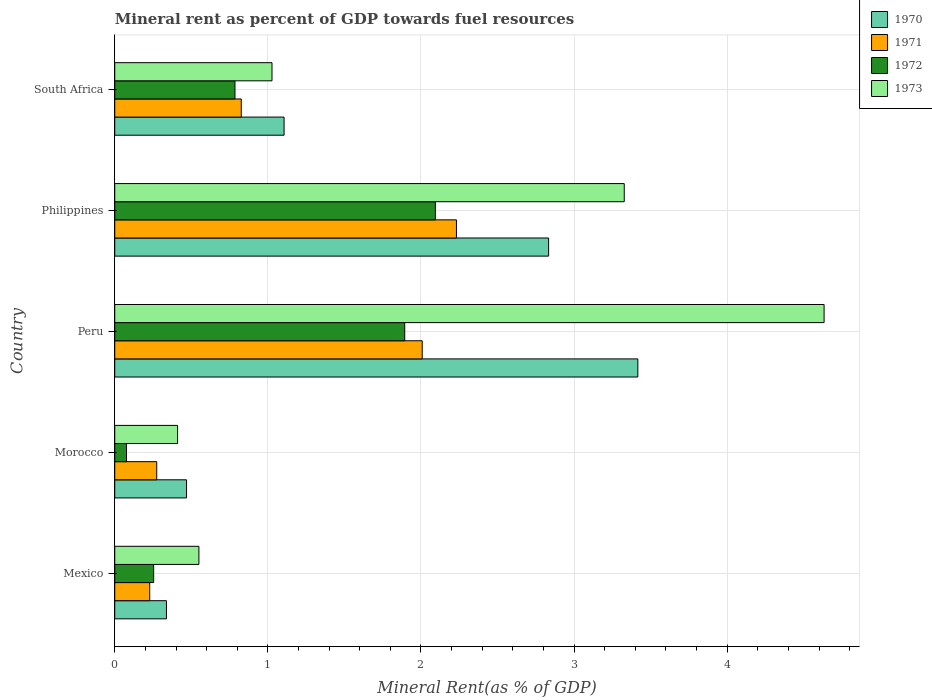How many different coloured bars are there?
Offer a terse response. 4. How many groups of bars are there?
Make the answer very short. 5. Are the number of bars per tick equal to the number of legend labels?
Your answer should be compact. Yes. Are the number of bars on each tick of the Y-axis equal?
Your response must be concise. Yes. What is the label of the 1st group of bars from the top?
Provide a short and direct response. South Africa. What is the mineral rent in 1970 in Morocco?
Give a very brief answer. 0.47. Across all countries, what is the maximum mineral rent in 1972?
Give a very brief answer. 2.09. Across all countries, what is the minimum mineral rent in 1973?
Give a very brief answer. 0.41. In which country was the mineral rent in 1972 maximum?
Your answer should be very brief. Philippines. In which country was the mineral rent in 1972 minimum?
Your answer should be very brief. Morocco. What is the total mineral rent in 1971 in the graph?
Keep it short and to the point. 5.57. What is the difference between the mineral rent in 1973 in Philippines and that in South Africa?
Provide a short and direct response. 2.3. What is the difference between the mineral rent in 1973 in South Africa and the mineral rent in 1971 in Peru?
Keep it short and to the point. -0.98. What is the average mineral rent in 1970 per country?
Keep it short and to the point. 1.63. What is the difference between the mineral rent in 1971 and mineral rent in 1972 in Peru?
Your response must be concise. 0.11. What is the ratio of the mineral rent in 1973 in Peru to that in Philippines?
Provide a succinct answer. 1.39. What is the difference between the highest and the second highest mineral rent in 1970?
Your response must be concise. 0.58. What is the difference between the highest and the lowest mineral rent in 1970?
Keep it short and to the point. 3.08. In how many countries, is the mineral rent in 1973 greater than the average mineral rent in 1973 taken over all countries?
Your response must be concise. 2. Is the sum of the mineral rent in 1972 in Philippines and South Africa greater than the maximum mineral rent in 1971 across all countries?
Your answer should be very brief. Yes. Is it the case that in every country, the sum of the mineral rent in 1973 and mineral rent in 1971 is greater than the sum of mineral rent in 1970 and mineral rent in 1972?
Ensure brevity in your answer.  No. What does the 3rd bar from the top in South Africa represents?
Provide a short and direct response. 1971. What does the 1st bar from the bottom in Morocco represents?
Give a very brief answer. 1970. Is it the case that in every country, the sum of the mineral rent in 1970 and mineral rent in 1971 is greater than the mineral rent in 1973?
Ensure brevity in your answer.  Yes. How many bars are there?
Your answer should be very brief. 20. How many countries are there in the graph?
Provide a short and direct response. 5. Are the values on the major ticks of X-axis written in scientific E-notation?
Provide a short and direct response. No. Does the graph contain any zero values?
Provide a short and direct response. No. How many legend labels are there?
Your answer should be compact. 4. What is the title of the graph?
Offer a terse response. Mineral rent as percent of GDP towards fuel resources. Does "1964" appear as one of the legend labels in the graph?
Your answer should be compact. No. What is the label or title of the X-axis?
Make the answer very short. Mineral Rent(as % of GDP). What is the label or title of the Y-axis?
Your response must be concise. Country. What is the Mineral Rent(as % of GDP) of 1970 in Mexico?
Offer a very short reply. 0.34. What is the Mineral Rent(as % of GDP) in 1971 in Mexico?
Ensure brevity in your answer.  0.23. What is the Mineral Rent(as % of GDP) of 1972 in Mexico?
Keep it short and to the point. 0.25. What is the Mineral Rent(as % of GDP) in 1973 in Mexico?
Your response must be concise. 0.55. What is the Mineral Rent(as % of GDP) of 1970 in Morocco?
Your answer should be compact. 0.47. What is the Mineral Rent(as % of GDP) of 1971 in Morocco?
Offer a very short reply. 0.27. What is the Mineral Rent(as % of GDP) of 1972 in Morocco?
Provide a succinct answer. 0.08. What is the Mineral Rent(as % of GDP) of 1973 in Morocco?
Your answer should be very brief. 0.41. What is the Mineral Rent(as % of GDP) in 1970 in Peru?
Offer a very short reply. 3.42. What is the Mineral Rent(as % of GDP) of 1971 in Peru?
Your answer should be compact. 2.01. What is the Mineral Rent(as % of GDP) in 1972 in Peru?
Offer a very short reply. 1.89. What is the Mineral Rent(as % of GDP) in 1973 in Peru?
Give a very brief answer. 4.63. What is the Mineral Rent(as % of GDP) in 1970 in Philippines?
Provide a short and direct response. 2.83. What is the Mineral Rent(as % of GDP) of 1971 in Philippines?
Ensure brevity in your answer.  2.23. What is the Mineral Rent(as % of GDP) of 1972 in Philippines?
Ensure brevity in your answer.  2.09. What is the Mineral Rent(as % of GDP) of 1973 in Philippines?
Give a very brief answer. 3.33. What is the Mineral Rent(as % of GDP) in 1970 in South Africa?
Make the answer very short. 1.11. What is the Mineral Rent(as % of GDP) in 1971 in South Africa?
Keep it short and to the point. 0.83. What is the Mineral Rent(as % of GDP) in 1972 in South Africa?
Offer a very short reply. 0.79. What is the Mineral Rent(as % of GDP) in 1973 in South Africa?
Offer a terse response. 1.03. Across all countries, what is the maximum Mineral Rent(as % of GDP) in 1970?
Provide a short and direct response. 3.42. Across all countries, what is the maximum Mineral Rent(as % of GDP) of 1971?
Make the answer very short. 2.23. Across all countries, what is the maximum Mineral Rent(as % of GDP) of 1972?
Give a very brief answer. 2.09. Across all countries, what is the maximum Mineral Rent(as % of GDP) in 1973?
Your answer should be very brief. 4.63. Across all countries, what is the minimum Mineral Rent(as % of GDP) of 1970?
Provide a short and direct response. 0.34. Across all countries, what is the minimum Mineral Rent(as % of GDP) of 1971?
Your response must be concise. 0.23. Across all countries, what is the minimum Mineral Rent(as % of GDP) of 1972?
Provide a short and direct response. 0.08. Across all countries, what is the minimum Mineral Rent(as % of GDP) in 1973?
Your answer should be compact. 0.41. What is the total Mineral Rent(as % of GDP) in 1970 in the graph?
Give a very brief answer. 8.16. What is the total Mineral Rent(as % of GDP) in 1971 in the graph?
Give a very brief answer. 5.57. What is the total Mineral Rent(as % of GDP) of 1972 in the graph?
Keep it short and to the point. 5.1. What is the total Mineral Rent(as % of GDP) of 1973 in the graph?
Give a very brief answer. 9.95. What is the difference between the Mineral Rent(as % of GDP) of 1970 in Mexico and that in Morocco?
Make the answer very short. -0.13. What is the difference between the Mineral Rent(as % of GDP) in 1971 in Mexico and that in Morocco?
Your answer should be compact. -0.05. What is the difference between the Mineral Rent(as % of GDP) of 1972 in Mexico and that in Morocco?
Your answer should be very brief. 0.18. What is the difference between the Mineral Rent(as % of GDP) in 1973 in Mexico and that in Morocco?
Your answer should be very brief. 0.14. What is the difference between the Mineral Rent(as % of GDP) in 1970 in Mexico and that in Peru?
Provide a succinct answer. -3.08. What is the difference between the Mineral Rent(as % of GDP) of 1971 in Mexico and that in Peru?
Ensure brevity in your answer.  -1.78. What is the difference between the Mineral Rent(as % of GDP) of 1972 in Mexico and that in Peru?
Your response must be concise. -1.64. What is the difference between the Mineral Rent(as % of GDP) of 1973 in Mexico and that in Peru?
Give a very brief answer. -4.08. What is the difference between the Mineral Rent(as % of GDP) in 1970 in Mexico and that in Philippines?
Offer a terse response. -2.5. What is the difference between the Mineral Rent(as % of GDP) in 1971 in Mexico and that in Philippines?
Provide a short and direct response. -2. What is the difference between the Mineral Rent(as % of GDP) of 1972 in Mexico and that in Philippines?
Your response must be concise. -1.84. What is the difference between the Mineral Rent(as % of GDP) of 1973 in Mexico and that in Philippines?
Give a very brief answer. -2.78. What is the difference between the Mineral Rent(as % of GDP) of 1970 in Mexico and that in South Africa?
Give a very brief answer. -0.77. What is the difference between the Mineral Rent(as % of GDP) of 1971 in Mexico and that in South Africa?
Ensure brevity in your answer.  -0.6. What is the difference between the Mineral Rent(as % of GDP) of 1972 in Mexico and that in South Africa?
Keep it short and to the point. -0.53. What is the difference between the Mineral Rent(as % of GDP) in 1973 in Mexico and that in South Africa?
Give a very brief answer. -0.48. What is the difference between the Mineral Rent(as % of GDP) of 1970 in Morocco and that in Peru?
Your answer should be compact. -2.95. What is the difference between the Mineral Rent(as % of GDP) in 1971 in Morocco and that in Peru?
Offer a very short reply. -1.73. What is the difference between the Mineral Rent(as % of GDP) of 1972 in Morocco and that in Peru?
Your answer should be very brief. -1.82. What is the difference between the Mineral Rent(as % of GDP) of 1973 in Morocco and that in Peru?
Give a very brief answer. -4.22. What is the difference between the Mineral Rent(as % of GDP) in 1970 in Morocco and that in Philippines?
Keep it short and to the point. -2.36. What is the difference between the Mineral Rent(as % of GDP) of 1971 in Morocco and that in Philippines?
Make the answer very short. -1.96. What is the difference between the Mineral Rent(as % of GDP) in 1972 in Morocco and that in Philippines?
Your answer should be very brief. -2.02. What is the difference between the Mineral Rent(as % of GDP) in 1973 in Morocco and that in Philippines?
Offer a very short reply. -2.92. What is the difference between the Mineral Rent(as % of GDP) of 1970 in Morocco and that in South Africa?
Ensure brevity in your answer.  -0.64. What is the difference between the Mineral Rent(as % of GDP) in 1971 in Morocco and that in South Africa?
Ensure brevity in your answer.  -0.55. What is the difference between the Mineral Rent(as % of GDP) of 1972 in Morocco and that in South Africa?
Your response must be concise. -0.71. What is the difference between the Mineral Rent(as % of GDP) in 1973 in Morocco and that in South Africa?
Provide a short and direct response. -0.62. What is the difference between the Mineral Rent(as % of GDP) in 1970 in Peru and that in Philippines?
Keep it short and to the point. 0.58. What is the difference between the Mineral Rent(as % of GDP) in 1971 in Peru and that in Philippines?
Provide a short and direct response. -0.22. What is the difference between the Mineral Rent(as % of GDP) in 1972 in Peru and that in Philippines?
Your response must be concise. -0.2. What is the difference between the Mineral Rent(as % of GDP) in 1973 in Peru and that in Philippines?
Offer a very short reply. 1.31. What is the difference between the Mineral Rent(as % of GDP) of 1970 in Peru and that in South Africa?
Offer a terse response. 2.31. What is the difference between the Mineral Rent(as % of GDP) of 1971 in Peru and that in South Africa?
Offer a terse response. 1.18. What is the difference between the Mineral Rent(as % of GDP) of 1972 in Peru and that in South Africa?
Your response must be concise. 1.11. What is the difference between the Mineral Rent(as % of GDP) of 1973 in Peru and that in South Africa?
Offer a very short reply. 3.61. What is the difference between the Mineral Rent(as % of GDP) of 1970 in Philippines and that in South Africa?
Your answer should be compact. 1.73. What is the difference between the Mineral Rent(as % of GDP) of 1971 in Philippines and that in South Africa?
Provide a short and direct response. 1.41. What is the difference between the Mineral Rent(as % of GDP) in 1972 in Philippines and that in South Africa?
Your answer should be compact. 1.31. What is the difference between the Mineral Rent(as % of GDP) in 1973 in Philippines and that in South Africa?
Offer a very short reply. 2.3. What is the difference between the Mineral Rent(as % of GDP) in 1970 in Mexico and the Mineral Rent(as % of GDP) in 1971 in Morocco?
Ensure brevity in your answer.  0.06. What is the difference between the Mineral Rent(as % of GDP) of 1970 in Mexico and the Mineral Rent(as % of GDP) of 1972 in Morocco?
Keep it short and to the point. 0.26. What is the difference between the Mineral Rent(as % of GDP) of 1970 in Mexico and the Mineral Rent(as % of GDP) of 1973 in Morocco?
Ensure brevity in your answer.  -0.07. What is the difference between the Mineral Rent(as % of GDP) in 1971 in Mexico and the Mineral Rent(as % of GDP) in 1972 in Morocco?
Your response must be concise. 0.15. What is the difference between the Mineral Rent(as % of GDP) of 1971 in Mexico and the Mineral Rent(as % of GDP) of 1973 in Morocco?
Your answer should be very brief. -0.18. What is the difference between the Mineral Rent(as % of GDP) of 1972 in Mexico and the Mineral Rent(as % of GDP) of 1973 in Morocco?
Give a very brief answer. -0.16. What is the difference between the Mineral Rent(as % of GDP) in 1970 in Mexico and the Mineral Rent(as % of GDP) in 1971 in Peru?
Provide a succinct answer. -1.67. What is the difference between the Mineral Rent(as % of GDP) of 1970 in Mexico and the Mineral Rent(as % of GDP) of 1972 in Peru?
Ensure brevity in your answer.  -1.56. What is the difference between the Mineral Rent(as % of GDP) in 1970 in Mexico and the Mineral Rent(as % of GDP) in 1973 in Peru?
Keep it short and to the point. -4.29. What is the difference between the Mineral Rent(as % of GDP) in 1971 in Mexico and the Mineral Rent(as % of GDP) in 1972 in Peru?
Provide a short and direct response. -1.67. What is the difference between the Mineral Rent(as % of GDP) in 1971 in Mexico and the Mineral Rent(as % of GDP) in 1973 in Peru?
Offer a terse response. -4.4. What is the difference between the Mineral Rent(as % of GDP) of 1972 in Mexico and the Mineral Rent(as % of GDP) of 1973 in Peru?
Give a very brief answer. -4.38. What is the difference between the Mineral Rent(as % of GDP) of 1970 in Mexico and the Mineral Rent(as % of GDP) of 1971 in Philippines?
Offer a terse response. -1.89. What is the difference between the Mineral Rent(as % of GDP) of 1970 in Mexico and the Mineral Rent(as % of GDP) of 1972 in Philippines?
Make the answer very short. -1.76. What is the difference between the Mineral Rent(as % of GDP) in 1970 in Mexico and the Mineral Rent(as % of GDP) in 1973 in Philippines?
Keep it short and to the point. -2.99. What is the difference between the Mineral Rent(as % of GDP) in 1971 in Mexico and the Mineral Rent(as % of GDP) in 1972 in Philippines?
Make the answer very short. -1.87. What is the difference between the Mineral Rent(as % of GDP) of 1971 in Mexico and the Mineral Rent(as % of GDP) of 1973 in Philippines?
Keep it short and to the point. -3.1. What is the difference between the Mineral Rent(as % of GDP) in 1972 in Mexico and the Mineral Rent(as % of GDP) in 1973 in Philippines?
Offer a very short reply. -3.07. What is the difference between the Mineral Rent(as % of GDP) of 1970 in Mexico and the Mineral Rent(as % of GDP) of 1971 in South Africa?
Your response must be concise. -0.49. What is the difference between the Mineral Rent(as % of GDP) of 1970 in Mexico and the Mineral Rent(as % of GDP) of 1972 in South Africa?
Your answer should be compact. -0.45. What is the difference between the Mineral Rent(as % of GDP) in 1970 in Mexico and the Mineral Rent(as % of GDP) in 1973 in South Africa?
Your response must be concise. -0.69. What is the difference between the Mineral Rent(as % of GDP) in 1971 in Mexico and the Mineral Rent(as % of GDP) in 1972 in South Africa?
Your answer should be very brief. -0.56. What is the difference between the Mineral Rent(as % of GDP) in 1971 in Mexico and the Mineral Rent(as % of GDP) in 1973 in South Africa?
Your answer should be very brief. -0.8. What is the difference between the Mineral Rent(as % of GDP) in 1972 in Mexico and the Mineral Rent(as % of GDP) in 1973 in South Africa?
Offer a terse response. -0.77. What is the difference between the Mineral Rent(as % of GDP) of 1970 in Morocco and the Mineral Rent(as % of GDP) of 1971 in Peru?
Your answer should be compact. -1.54. What is the difference between the Mineral Rent(as % of GDP) in 1970 in Morocco and the Mineral Rent(as % of GDP) in 1972 in Peru?
Offer a terse response. -1.43. What is the difference between the Mineral Rent(as % of GDP) of 1970 in Morocco and the Mineral Rent(as % of GDP) of 1973 in Peru?
Keep it short and to the point. -4.16. What is the difference between the Mineral Rent(as % of GDP) of 1971 in Morocco and the Mineral Rent(as % of GDP) of 1972 in Peru?
Offer a very short reply. -1.62. What is the difference between the Mineral Rent(as % of GDP) in 1971 in Morocco and the Mineral Rent(as % of GDP) in 1973 in Peru?
Offer a terse response. -4.36. What is the difference between the Mineral Rent(as % of GDP) of 1972 in Morocco and the Mineral Rent(as % of GDP) of 1973 in Peru?
Provide a succinct answer. -4.56. What is the difference between the Mineral Rent(as % of GDP) in 1970 in Morocco and the Mineral Rent(as % of GDP) in 1971 in Philippines?
Provide a short and direct response. -1.76. What is the difference between the Mineral Rent(as % of GDP) of 1970 in Morocco and the Mineral Rent(as % of GDP) of 1972 in Philippines?
Your response must be concise. -1.63. What is the difference between the Mineral Rent(as % of GDP) of 1970 in Morocco and the Mineral Rent(as % of GDP) of 1973 in Philippines?
Your response must be concise. -2.86. What is the difference between the Mineral Rent(as % of GDP) in 1971 in Morocco and the Mineral Rent(as % of GDP) in 1972 in Philippines?
Ensure brevity in your answer.  -1.82. What is the difference between the Mineral Rent(as % of GDP) in 1971 in Morocco and the Mineral Rent(as % of GDP) in 1973 in Philippines?
Offer a very short reply. -3.05. What is the difference between the Mineral Rent(as % of GDP) in 1972 in Morocco and the Mineral Rent(as % of GDP) in 1973 in Philippines?
Give a very brief answer. -3.25. What is the difference between the Mineral Rent(as % of GDP) in 1970 in Morocco and the Mineral Rent(as % of GDP) in 1971 in South Africa?
Offer a very short reply. -0.36. What is the difference between the Mineral Rent(as % of GDP) in 1970 in Morocco and the Mineral Rent(as % of GDP) in 1972 in South Africa?
Offer a terse response. -0.32. What is the difference between the Mineral Rent(as % of GDP) in 1970 in Morocco and the Mineral Rent(as % of GDP) in 1973 in South Africa?
Give a very brief answer. -0.56. What is the difference between the Mineral Rent(as % of GDP) in 1971 in Morocco and the Mineral Rent(as % of GDP) in 1972 in South Africa?
Offer a terse response. -0.51. What is the difference between the Mineral Rent(as % of GDP) of 1971 in Morocco and the Mineral Rent(as % of GDP) of 1973 in South Africa?
Ensure brevity in your answer.  -0.75. What is the difference between the Mineral Rent(as % of GDP) in 1972 in Morocco and the Mineral Rent(as % of GDP) in 1973 in South Africa?
Your answer should be compact. -0.95. What is the difference between the Mineral Rent(as % of GDP) of 1970 in Peru and the Mineral Rent(as % of GDP) of 1971 in Philippines?
Keep it short and to the point. 1.18. What is the difference between the Mineral Rent(as % of GDP) in 1970 in Peru and the Mineral Rent(as % of GDP) in 1972 in Philippines?
Your answer should be compact. 1.32. What is the difference between the Mineral Rent(as % of GDP) in 1970 in Peru and the Mineral Rent(as % of GDP) in 1973 in Philippines?
Provide a succinct answer. 0.09. What is the difference between the Mineral Rent(as % of GDP) of 1971 in Peru and the Mineral Rent(as % of GDP) of 1972 in Philippines?
Your response must be concise. -0.09. What is the difference between the Mineral Rent(as % of GDP) of 1971 in Peru and the Mineral Rent(as % of GDP) of 1973 in Philippines?
Keep it short and to the point. -1.32. What is the difference between the Mineral Rent(as % of GDP) of 1972 in Peru and the Mineral Rent(as % of GDP) of 1973 in Philippines?
Offer a terse response. -1.43. What is the difference between the Mineral Rent(as % of GDP) of 1970 in Peru and the Mineral Rent(as % of GDP) of 1971 in South Africa?
Provide a succinct answer. 2.59. What is the difference between the Mineral Rent(as % of GDP) in 1970 in Peru and the Mineral Rent(as % of GDP) in 1972 in South Africa?
Keep it short and to the point. 2.63. What is the difference between the Mineral Rent(as % of GDP) of 1970 in Peru and the Mineral Rent(as % of GDP) of 1973 in South Africa?
Ensure brevity in your answer.  2.39. What is the difference between the Mineral Rent(as % of GDP) in 1971 in Peru and the Mineral Rent(as % of GDP) in 1972 in South Africa?
Give a very brief answer. 1.22. What is the difference between the Mineral Rent(as % of GDP) of 1971 in Peru and the Mineral Rent(as % of GDP) of 1973 in South Africa?
Make the answer very short. 0.98. What is the difference between the Mineral Rent(as % of GDP) in 1972 in Peru and the Mineral Rent(as % of GDP) in 1973 in South Africa?
Offer a terse response. 0.87. What is the difference between the Mineral Rent(as % of GDP) in 1970 in Philippines and the Mineral Rent(as % of GDP) in 1971 in South Africa?
Your answer should be very brief. 2.01. What is the difference between the Mineral Rent(as % of GDP) in 1970 in Philippines and the Mineral Rent(as % of GDP) in 1972 in South Africa?
Provide a short and direct response. 2.05. What is the difference between the Mineral Rent(as % of GDP) in 1970 in Philippines and the Mineral Rent(as % of GDP) in 1973 in South Africa?
Provide a short and direct response. 1.81. What is the difference between the Mineral Rent(as % of GDP) in 1971 in Philippines and the Mineral Rent(as % of GDP) in 1972 in South Africa?
Your response must be concise. 1.45. What is the difference between the Mineral Rent(as % of GDP) of 1971 in Philippines and the Mineral Rent(as % of GDP) of 1973 in South Africa?
Ensure brevity in your answer.  1.2. What is the difference between the Mineral Rent(as % of GDP) of 1972 in Philippines and the Mineral Rent(as % of GDP) of 1973 in South Africa?
Offer a very short reply. 1.07. What is the average Mineral Rent(as % of GDP) in 1970 per country?
Keep it short and to the point. 1.63. What is the average Mineral Rent(as % of GDP) of 1971 per country?
Keep it short and to the point. 1.11. What is the average Mineral Rent(as % of GDP) of 1972 per country?
Your answer should be compact. 1.02. What is the average Mineral Rent(as % of GDP) in 1973 per country?
Your answer should be very brief. 1.99. What is the difference between the Mineral Rent(as % of GDP) of 1970 and Mineral Rent(as % of GDP) of 1971 in Mexico?
Provide a succinct answer. 0.11. What is the difference between the Mineral Rent(as % of GDP) of 1970 and Mineral Rent(as % of GDP) of 1972 in Mexico?
Provide a short and direct response. 0.08. What is the difference between the Mineral Rent(as % of GDP) of 1970 and Mineral Rent(as % of GDP) of 1973 in Mexico?
Your answer should be compact. -0.21. What is the difference between the Mineral Rent(as % of GDP) in 1971 and Mineral Rent(as % of GDP) in 1972 in Mexico?
Provide a short and direct response. -0.03. What is the difference between the Mineral Rent(as % of GDP) in 1971 and Mineral Rent(as % of GDP) in 1973 in Mexico?
Give a very brief answer. -0.32. What is the difference between the Mineral Rent(as % of GDP) in 1972 and Mineral Rent(as % of GDP) in 1973 in Mexico?
Ensure brevity in your answer.  -0.3. What is the difference between the Mineral Rent(as % of GDP) of 1970 and Mineral Rent(as % of GDP) of 1971 in Morocco?
Provide a short and direct response. 0.19. What is the difference between the Mineral Rent(as % of GDP) of 1970 and Mineral Rent(as % of GDP) of 1972 in Morocco?
Make the answer very short. 0.39. What is the difference between the Mineral Rent(as % of GDP) of 1970 and Mineral Rent(as % of GDP) of 1973 in Morocco?
Provide a short and direct response. 0.06. What is the difference between the Mineral Rent(as % of GDP) of 1971 and Mineral Rent(as % of GDP) of 1972 in Morocco?
Offer a terse response. 0.2. What is the difference between the Mineral Rent(as % of GDP) of 1971 and Mineral Rent(as % of GDP) of 1973 in Morocco?
Ensure brevity in your answer.  -0.14. What is the difference between the Mineral Rent(as % of GDP) in 1972 and Mineral Rent(as % of GDP) in 1973 in Morocco?
Keep it short and to the point. -0.33. What is the difference between the Mineral Rent(as % of GDP) of 1970 and Mineral Rent(as % of GDP) of 1971 in Peru?
Make the answer very short. 1.41. What is the difference between the Mineral Rent(as % of GDP) of 1970 and Mineral Rent(as % of GDP) of 1972 in Peru?
Offer a terse response. 1.52. What is the difference between the Mineral Rent(as % of GDP) in 1970 and Mineral Rent(as % of GDP) in 1973 in Peru?
Your answer should be very brief. -1.22. What is the difference between the Mineral Rent(as % of GDP) of 1971 and Mineral Rent(as % of GDP) of 1972 in Peru?
Your answer should be very brief. 0.11. What is the difference between the Mineral Rent(as % of GDP) of 1971 and Mineral Rent(as % of GDP) of 1973 in Peru?
Offer a very short reply. -2.62. What is the difference between the Mineral Rent(as % of GDP) of 1972 and Mineral Rent(as % of GDP) of 1973 in Peru?
Offer a very short reply. -2.74. What is the difference between the Mineral Rent(as % of GDP) in 1970 and Mineral Rent(as % of GDP) in 1971 in Philippines?
Make the answer very short. 0.6. What is the difference between the Mineral Rent(as % of GDP) in 1970 and Mineral Rent(as % of GDP) in 1972 in Philippines?
Offer a very short reply. 0.74. What is the difference between the Mineral Rent(as % of GDP) in 1970 and Mineral Rent(as % of GDP) in 1973 in Philippines?
Offer a very short reply. -0.49. What is the difference between the Mineral Rent(as % of GDP) in 1971 and Mineral Rent(as % of GDP) in 1972 in Philippines?
Provide a short and direct response. 0.14. What is the difference between the Mineral Rent(as % of GDP) in 1971 and Mineral Rent(as % of GDP) in 1973 in Philippines?
Provide a succinct answer. -1.1. What is the difference between the Mineral Rent(as % of GDP) in 1972 and Mineral Rent(as % of GDP) in 1973 in Philippines?
Your answer should be very brief. -1.23. What is the difference between the Mineral Rent(as % of GDP) in 1970 and Mineral Rent(as % of GDP) in 1971 in South Africa?
Make the answer very short. 0.28. What is the difference between the Mineral Rent(as % of GDP) of 1970 and Mineral Rent(as % of GDP) of 1972 in South Africa?
Provide a short and direct response. 0.32. What is the difference between the Mineral Rent(as % of GDP) of 1970 and Mineral Rent(as % of GDP) of 1973 in South Africa?
Give a very brief answer. 0.08. What is the difference between the Mineral Rent(as % of GDP) of 1971 and Mineral Rent(as % of GDP) of 1972 in South Africa?
Your answer should be very brief. 0.04. What is the difference between the Mineral Rent(as % of GDP) of 1971 and Mineral Rent(as % of GDP) of 1973 in South Africa?
Keep it short and to the point. -0.2. What is the difference between the Mineral Rent(as % of GDP) in 1972 and Mineral Rent(as % of GDP) in 1973 in South Africa?
Make the answer very short. -0.24. What is the ratio of the Mineral Rent(as % of GDP) of 1970 in Mexico to that in Morocco?
Provide a short and direct response. 0.72. What is the ratio of the Mineral Rent(as % of GDP) in 1971 in Mexico to that in Morocco?
Offer a very short reply. 0.83. What is the ratio of the Mineral Rent(as % of GDP) in 1972 in Mexico to that in Morocco?
Make the answer very short. 3.31. What is the ratio of the Mineral Rent(as % of GDP) of 1973 in Mexico to that in Morocco?
Offer a terse response. 1.34. What is the ratio of the Mineral Rent(as % of GDP) in 1970 in Mexico to that in Peru?
Provide a succinct answer. 0.1. What is the ratio of the Mineral Rent(as % of GDP) in 1971 in Mexico to that in Peru?
Give a very brief answer. 0.11. What is the ratio of the Mineral Rent(as % of GDP) in 1972 in Mexico to that in Peru?
Keep it short and to the point. 0.13. What is the ratio of the Mineral Rent(as % of GDP) in 1973 in Mexico to that in Peru?
Provide a short and direct response. 0.12. What is the ratio of the Mineral Rent(as % of GDP) of 1970 in Mexico to that in Philippines?
Give a very brief answer. 0.12. What is the ratio of the Mineral Rent(as % of GDP) in 1971 in Mexico to that in Philippines?
Keep it short and to the point. 0.1. What is the ratio of the Mineral Rent(as % of GDP) of 1972 in Mexico to that in Philippines?
Keep it short and to the point. 0.12. What is the ratio of the Mineral Rent(as % of GDP) of 1973 in Mexico to that in Philippines?
Offer a terse response. 0.17. What is the ratio of the Mineral Rent(as % of GDP) in 1970 in Mexico to that in South Africa?
Ensure brevity in your answer.  0.31. What is the ratio of the Mineral Rent(as % of GDP) of 1971 in Mexico to that in South Africa?
Offer a terse response. 0.28. What is the ratio of the Mineral Rent(as % of GDP) of 1972 in Mexico to that in South Africa?
Make the answer very short. 0.32. What is the ratio of the Mineral Rent(as % of GDP) of 1973 in Mexico to that in South Africa?
Your response must be concise. 0.54. What is the ratio of the Mineral Rent(as % of GDP) of 1970 in Morocco to that in Peru?
Provide a short and direct response. 0.14. What is the ratio of the Mineral Rent(as % of GDP) of 1971 in Morocco to that in Peru?
Provide a short and direct response. 0.14. What is the ratio of the Mineral Rent(as % of GDP) of 1972 in Morocco to that in Peru?
Offer a terse response. 0.04. What is the ratio of the Mineral Rent(as % of GDP) of 1973 in Morocco to that in Peru?
Your answer should be very brief. 0.09. What is the ratio of the Mineral Rent(as % of GDP) in 1970 in Morocco to that in Philippines?
Offer a very short reply. 0.17. What is the ratio of the Mineral Rent(as % of GDP) of 1971 in Morocco to that in Philippines?
Make the answer very short. 0.12. What is the ratio of the Mineral Rent(as % of GDP) in 1972 in Morocco to that in Philippines?
Provide a succinct answer. 0.04. What is the ratio of the Mineral Rent(as % of GDP) in 1973 in Morocco to that in Philippines?
Your answer should be compact. 0.12. What is the ratio of the Mineral Rent(as % of GDP) of 1970 in Morocco to that in South Africa?
Keep it short and to the point. 0.42. What is the ratio of the Mineral Rent(as % of GDP) in 1971 in Morocco to that in South Africa?
Your answer should be very brief. 0.33. What is the ratio of the Mineral Rent(as % of GDP) of 1972 in Morocco to that in South Africa?
Your response must be concise. 0.1. What is the ratio of the Mineral Rent(as % of GDP) of 1973 in Morocco to that in South Africa?
Offer a very short reply. 0.4. What is the ratio of the Mineral Rent(as % of GDP) of 1970 in Peru to that in Philippines?
Offer a terse response. 1.21. What is the ratio of the Mineral Rent(as % of GDP) in 1971 in Peru to that in Philippines?
Your answer should be compact. 0.9. What is the ratio of the Mineral Rent(as % of GDP) in 1972 in Peru to that in Philippines?
Offer a terse response. 0.9. What is the ratio of the Mineral Rent(as % of GDP) in 1973 in Peru to that in Philippines?
Provide a short and direct response. 1.39. What is the ratio of the Mineral Rent(as % of GDP) in 1970 in Peru to that in South Africa?
Provide a succinct answer. 3.09. What is the ratio of the Mineral Rent(as % of GDP) of 1971 in Peru to that in South Africa?
Ensure brevity in your answer.  2.43. What is the ratio of the Mineral Rent(as % of GDP) of 1972 in Peru to that in South Africa?
Provide a short and direct response. 2.41. What is the ratio of the Mineral Rent(as % of GDP) in 1973 in Peru to that in South Africa?
Your answer should be very brief. 4.51. What is the ratio of the Mineral Rent(as % of GDP) in 1970 in Philippines to that in South Africa?
Your answer should be very brief. 2.56. What is the ratio of the Mineral Rent(as % of GDP) in 1971 in Philippines to that in South Africa?
Your answer should be compact. 2.7. What is the ratio of the Mineral Rent(as % of GDP) in 1972 in Philippines to that in South Africa?
Provide a succinct answer. 2.67. What is the ratio of the Mineral Rent(as % of GDP) of 1973 in Philippines to that in South Africa?
Make the answer very short. 3.24. What is the difference between the highest and the second highest Mineral Rent(as % of GDP) of 1970?
Offer a terse response. 0.58. What is the difference between the highest and the second highest Mineral Rent(as % of GDP) in 1971?
Provide a succinct answer. 0.22. What is the difference between the highest and the second highest Mineral Rent(as % of GDP) in 1972?
Make the answer very short. 0.2. What is the difference between the highest and the second highest Mineral Rent(as % of GDP) in 1973?
Give a very brief answer. 1.31. What is the difference between the highest and the lowest Mineral Rent(as % of GDP) of 1970?
Your answer should be very brief. 3.08. What is the difference between the highest and the lowest Mineral Rent(as % of GDP) of 1971?
Offer a very short reply. 2. What is the difference between the highest and the lowest Mineral Rent(as % of GDP) of 1972?
Provide a succinct answer. 2.02. What is the difference between the highest and the lowest Mineral Rent(as % of GDP) in 1973?
Offer a terse response. 4.22. 